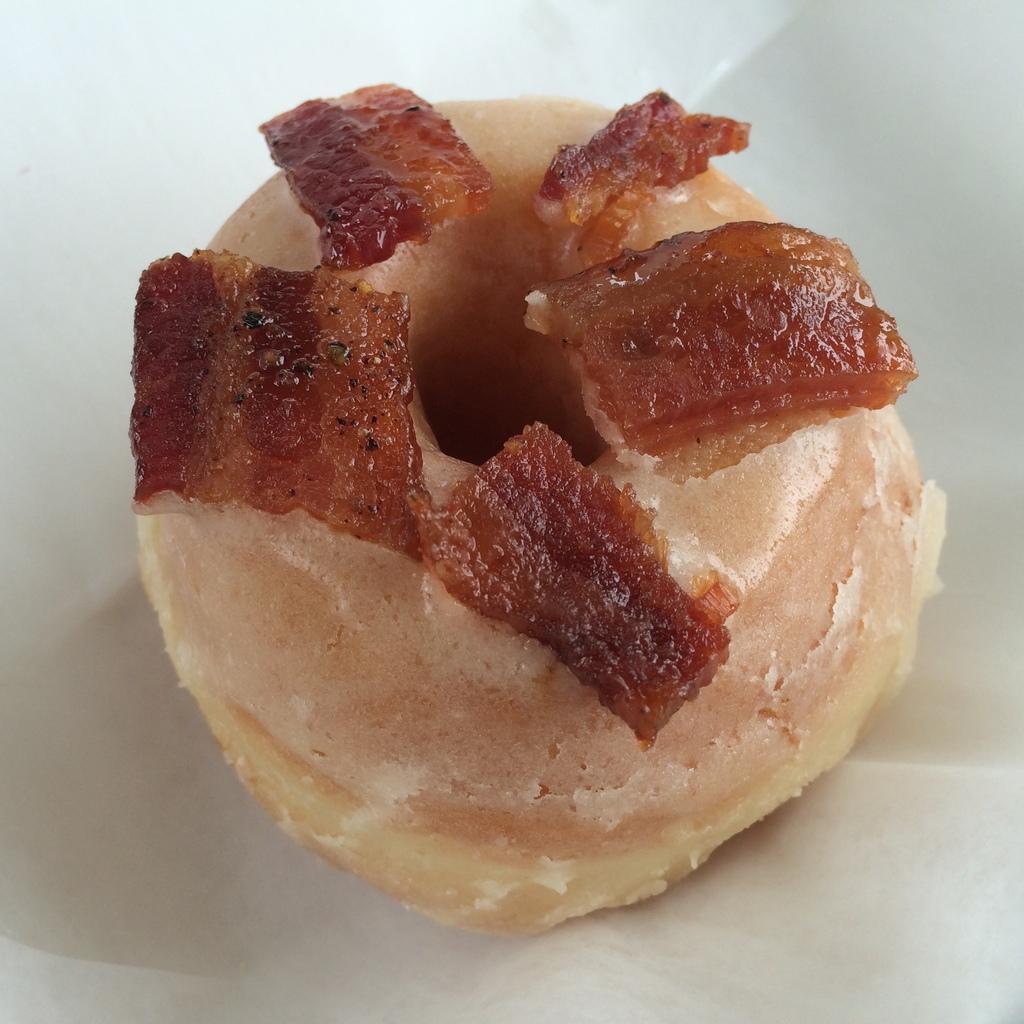In one or two sentences, can you explain what this image depicts? In this picture we can see a food item on a white surface. 